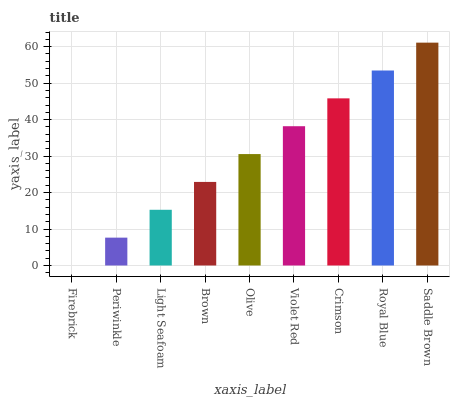Is Periwinkle the minimum?
Answer yes or no. No. Is Periwinkle the maximum?
Answer yes or no. No. Is Periwinkle greater than Firebrick?
Answer yes or no. Yes. Is Firebrick less than Periwinkle?
Answer yes or no. Yes. Is Firebrick greater than Periwinkle?
Answer yes or no. No. Is Periwinkle less than Firebrick?
Answer yes or no. No. Is Olive the high median?
Answer yes or no. Yes. Is Olive the low median?
Answer yes or no. Yes. Is Royal Blue the high median?
Answer yes or no. No. Is Violet Red the low median?
Answer yes or no. No. 